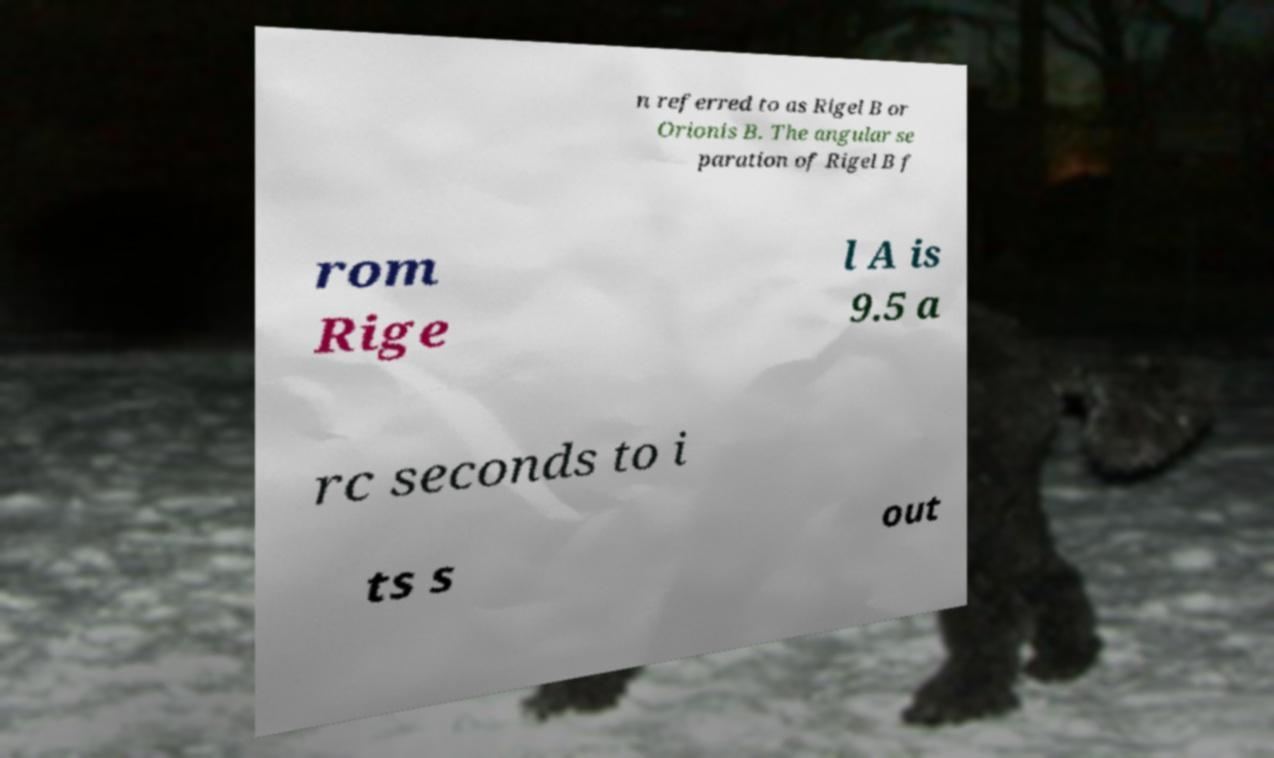There's text embedded in this image that I need extracted. Can you transcribe it verbatim? n referred to as Rigel B or Orionis B. The angular se paration of Rigel B f rom Rige l A is 9.5 a rc seconds to i ts s out 